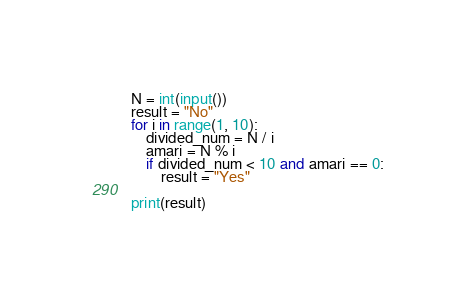<code> <loc_0><loc_0><loc_500><loc_500><_Python_>N = int(input())
result = "No"
for i in range(1, 10):
    divided_num = N / i
    amari = N % i
    if divided_num < 10 and amari == 0:
        result = "Yes"

print(result)</code> 